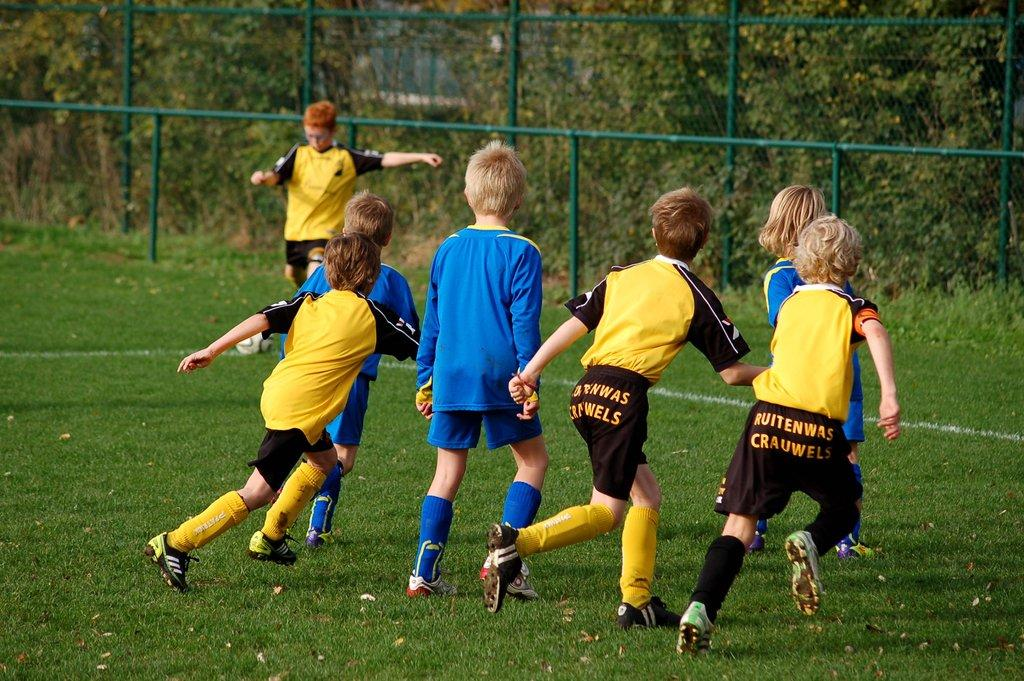<image>
Render a clear and concise summary of the photo. Two teams of children soccer players with the yellow ones having the ruitenwas crauwels logo on ther behind. 